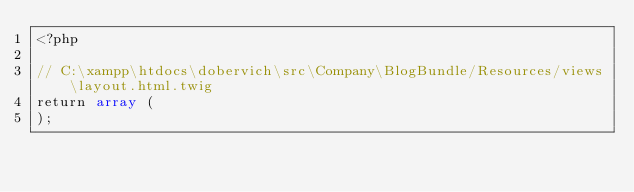Convert code to text. <code><loc_0><loc_0><loc_500><loc_500><_PHP_><?php

// C:\xampp\htdocs\dobervich\src\Company\BlogBundle/Resources/views\layout.html.twig
return array (
);
</code> 